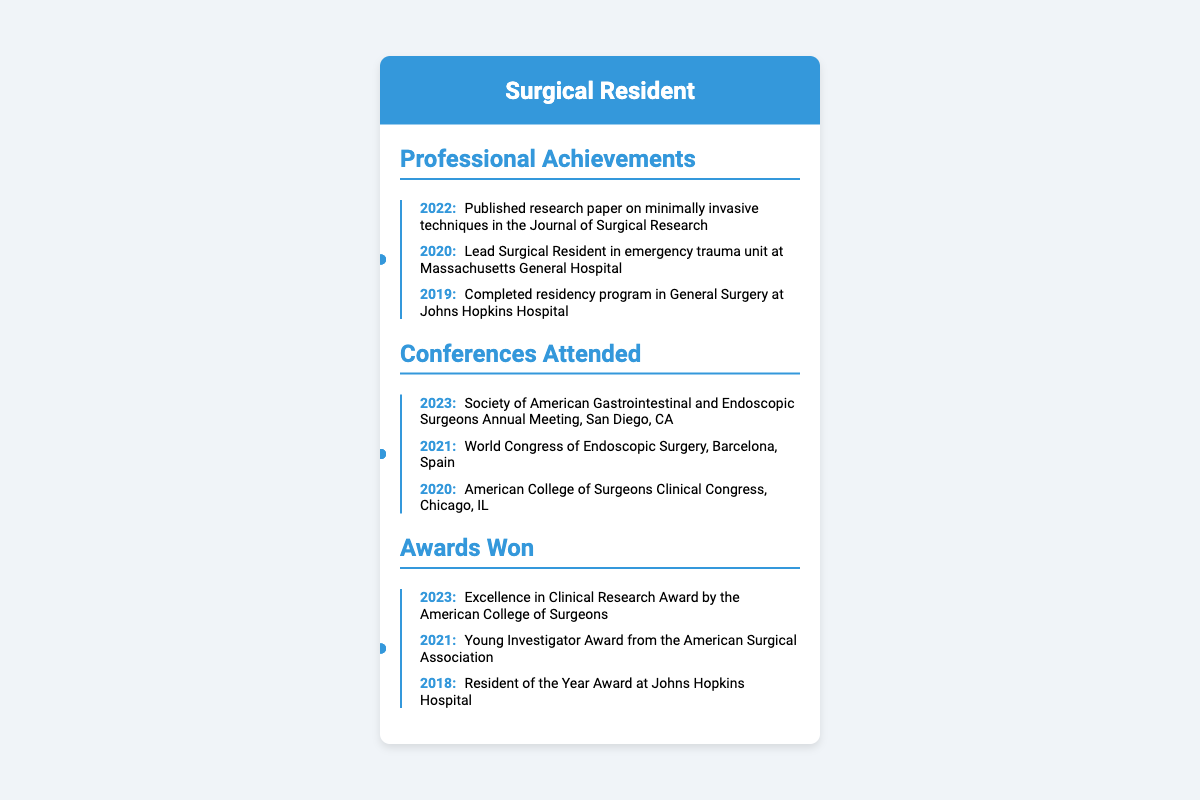what was the year of completion of the residency program? The residency program in General Surgery was completed in 2019, as stated in the timeline of professional achievements.
Answer: 2019 who won the Excellence in Clinical Research Award? The Excellence in Clinical Research Award was won by the surgical resident in 2023, as listed under awards won.
Answer: Surgical Resident which conference took place in 2021? The World Congress of Endoscopic Surgery took place in Barcelona, Spain in 2021, according to the conferences attended section.
Answer: World Congress of Endoscopic Surgery how many awards won are listed in the document? There are three awards won listed under the awards won section.
Answer: 3 what is the title of the published research paper? The published research paper is on minimally invasive techniques in the Journal of Surgical Research as mentioned in the professional achievements.
Answer: minimally invasive techniques which year did the surgical resident lead the emergency trauma unit? The surgical resident was the lead in the emergency trauma unit in 2020, as highlighted in the professional achievements.
Answer: 2020 where was the Society of American Gastrointestinal and Endoscopic Surgeons Annual Meeting held? It was held in San Diego, CA in 2023, according to the conferences attended section.
Answer: San Diego, CA what award did the surgical resident receive in 2018? The award received in 2018 was the Resident of the Year Award at Johns Hopkins Hospital as listed under awards won.
Answer: Resident of the Year Award who awarded the Young Investigator Award? The Young Investigator Award was given by the American Surgical Association in 2021, noted in the awards won section.
Answer: American Surgical Association 